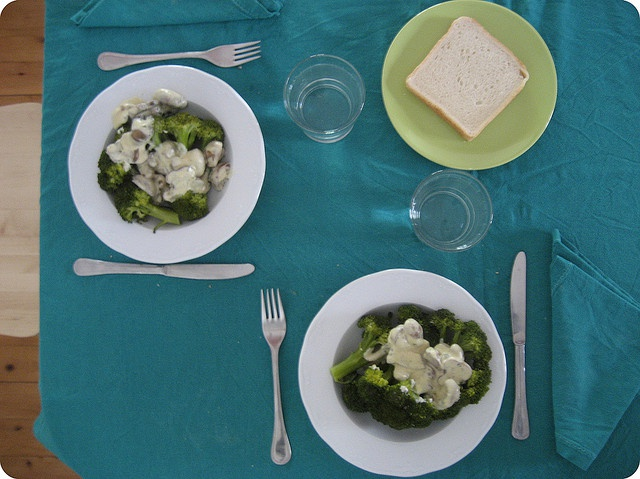Describe the objects in this image and their specific colors. I can see dining table in teal, white, darkgray, and olive tones, bowl in white, darkgray, black, and lightgray tones, bowl in white, lightgray, darkgray, and gray tones, broccoli in white, black, darkgreen, and gray tones, and cup in white and teal tones in this image. 